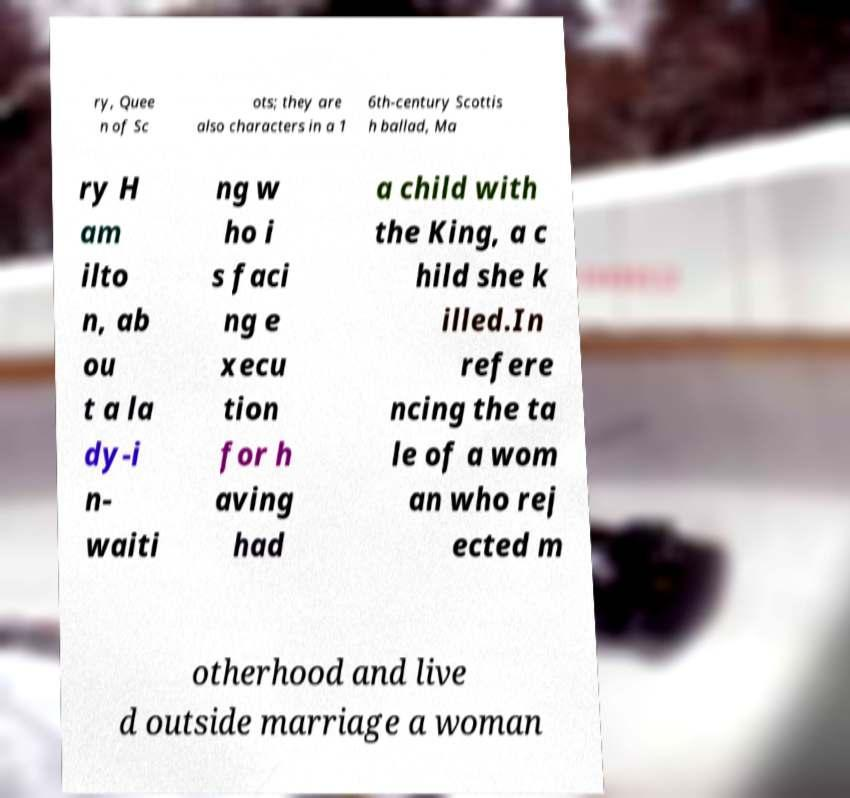Can you accurately transcribe the text from the provided image for me? ry, Quee n of Sc ots; they are also characters in a 1 6th-century Scottis h ballad, Ma ry H am ilto n, ab ou t a la dy-i n- waiti ng w ho i s faci ng e xecu tion for h aving had a child with the King, a c hild she k illed.In refere ncing the ta le of a wom an who rej ected m otherhood and live d outside marriage a woman 